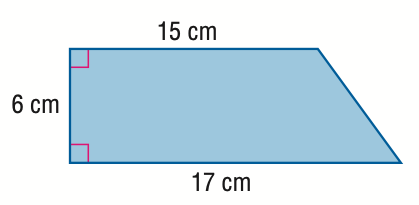Answer the mathemtical geometry problem and directly provide the correct option letter.
Question: Find the area of the trapezoid.
Choices: A: 44.3 B: 48 C: 96 D: 192 C 